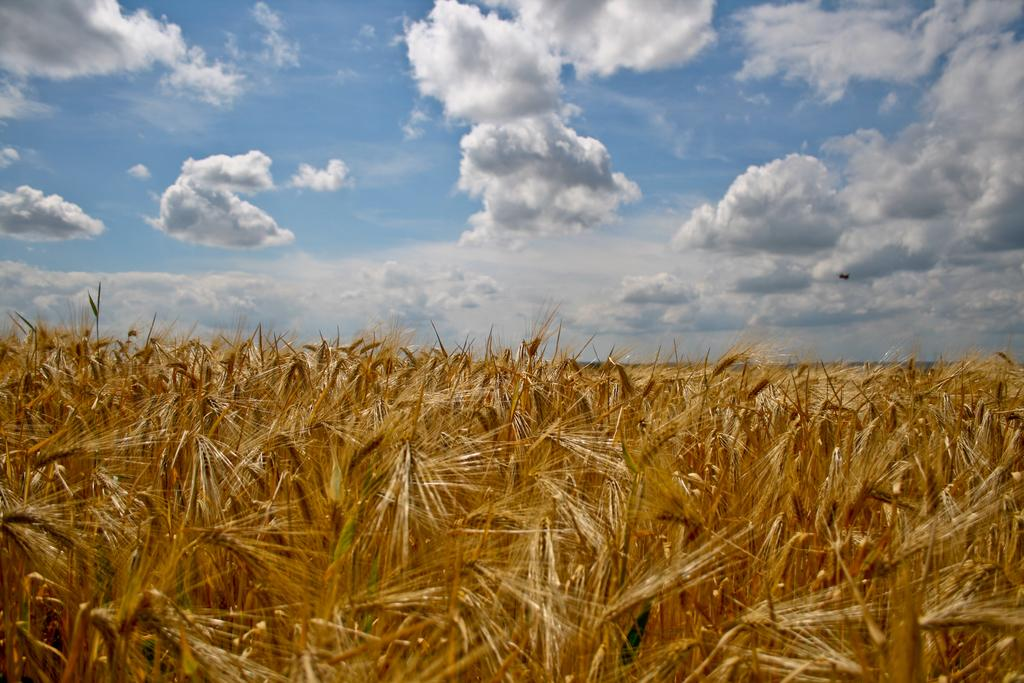What type of vegetation can be seen in the image? There is dry grass in the image. What colors are present in the grass? The grass has brown and green colors. What colors can be seen in the sky in the image? The sky is blue and white in color. What type of tooth is visible in the image? There is no tooth present in the image; it features dry grass and a blue and white sky. 